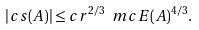<formula> <loc_0><loc_0><loc_500><loc_500>| c s ( A ) | \leq c r ^ { 2 / 3 } \ m c { E } ( A ) ^ { 4 / 3 } .</formula> 